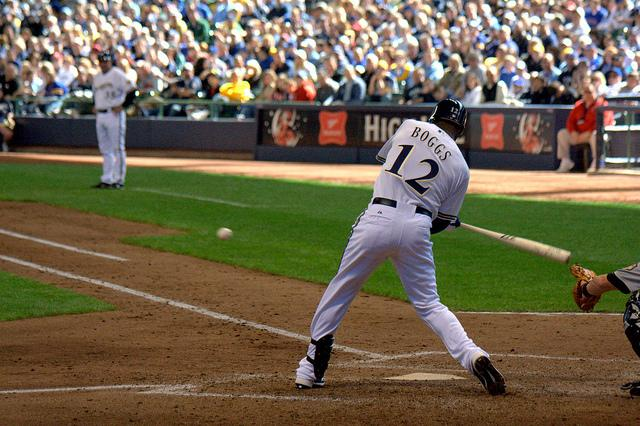Why cricketers wear white?

Choices:
A) reduces heat
B) peace
C) unique
D) dress code reduces heat 